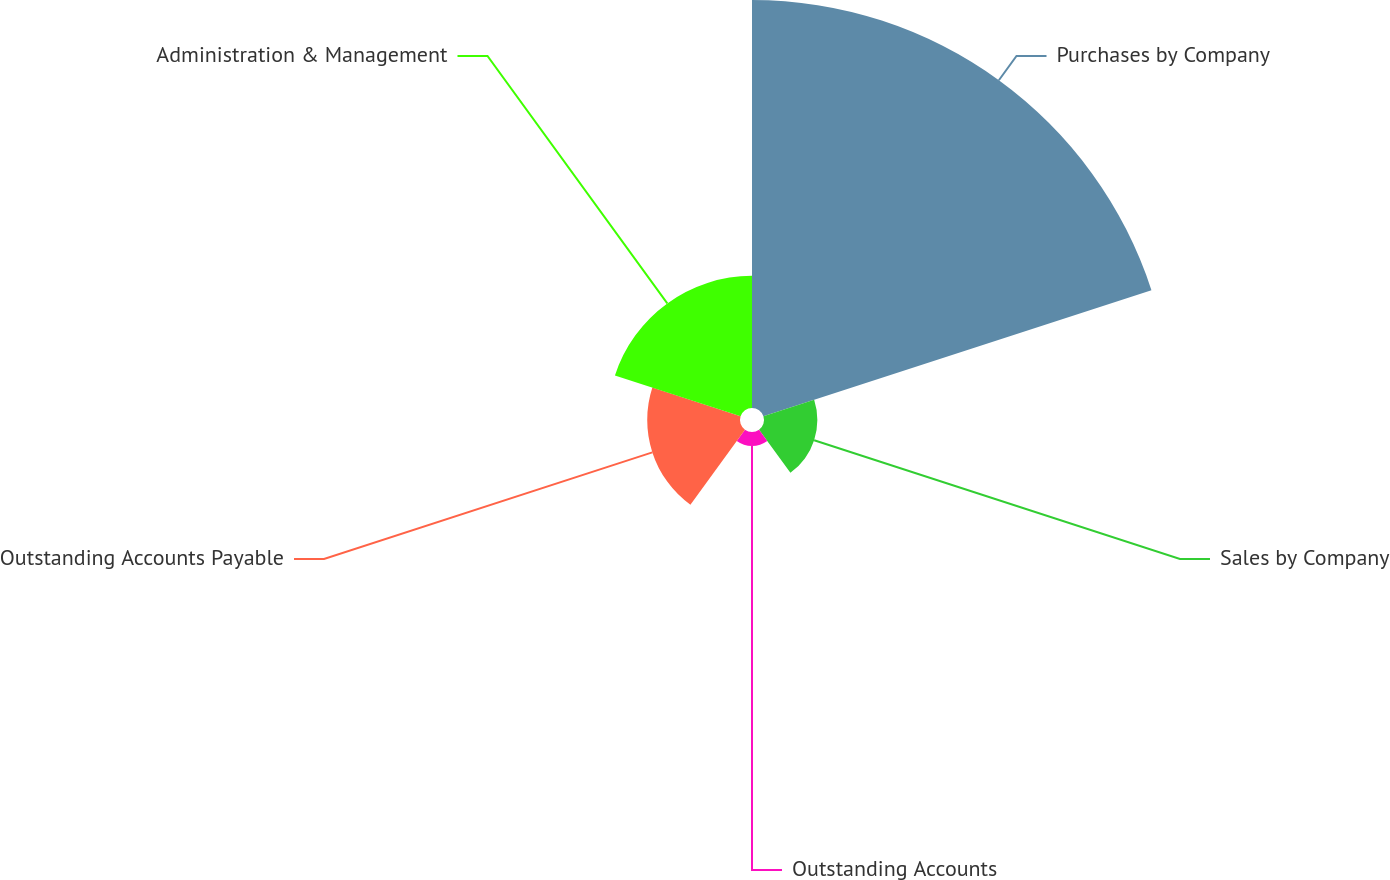<chart> <loc_0><loc_0><loc_500><loc_500><pie_chart><fcel>Purchases by Company<fcel>Sales by Company<fcel>Outstanding Accounts<fcel>Outstanding Accounts Payable<fcel>Administration & Management<nl><fcel>58.27%<fcel>7.62%<fcel>1.99%<fcel>13.25%<fcel>18.87%<nl></chart> 